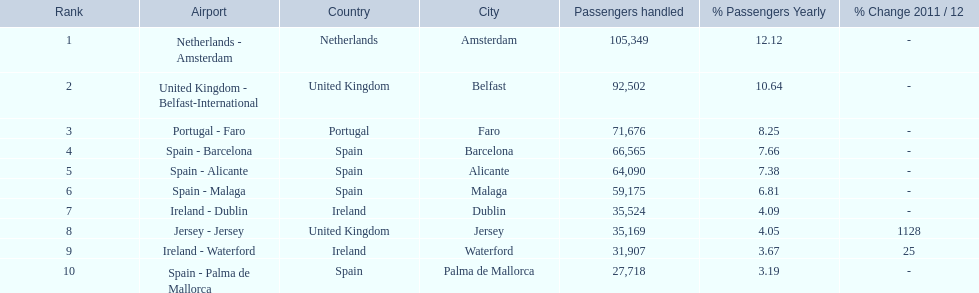How many passengers were handled in an airport in spain? 217,548. 